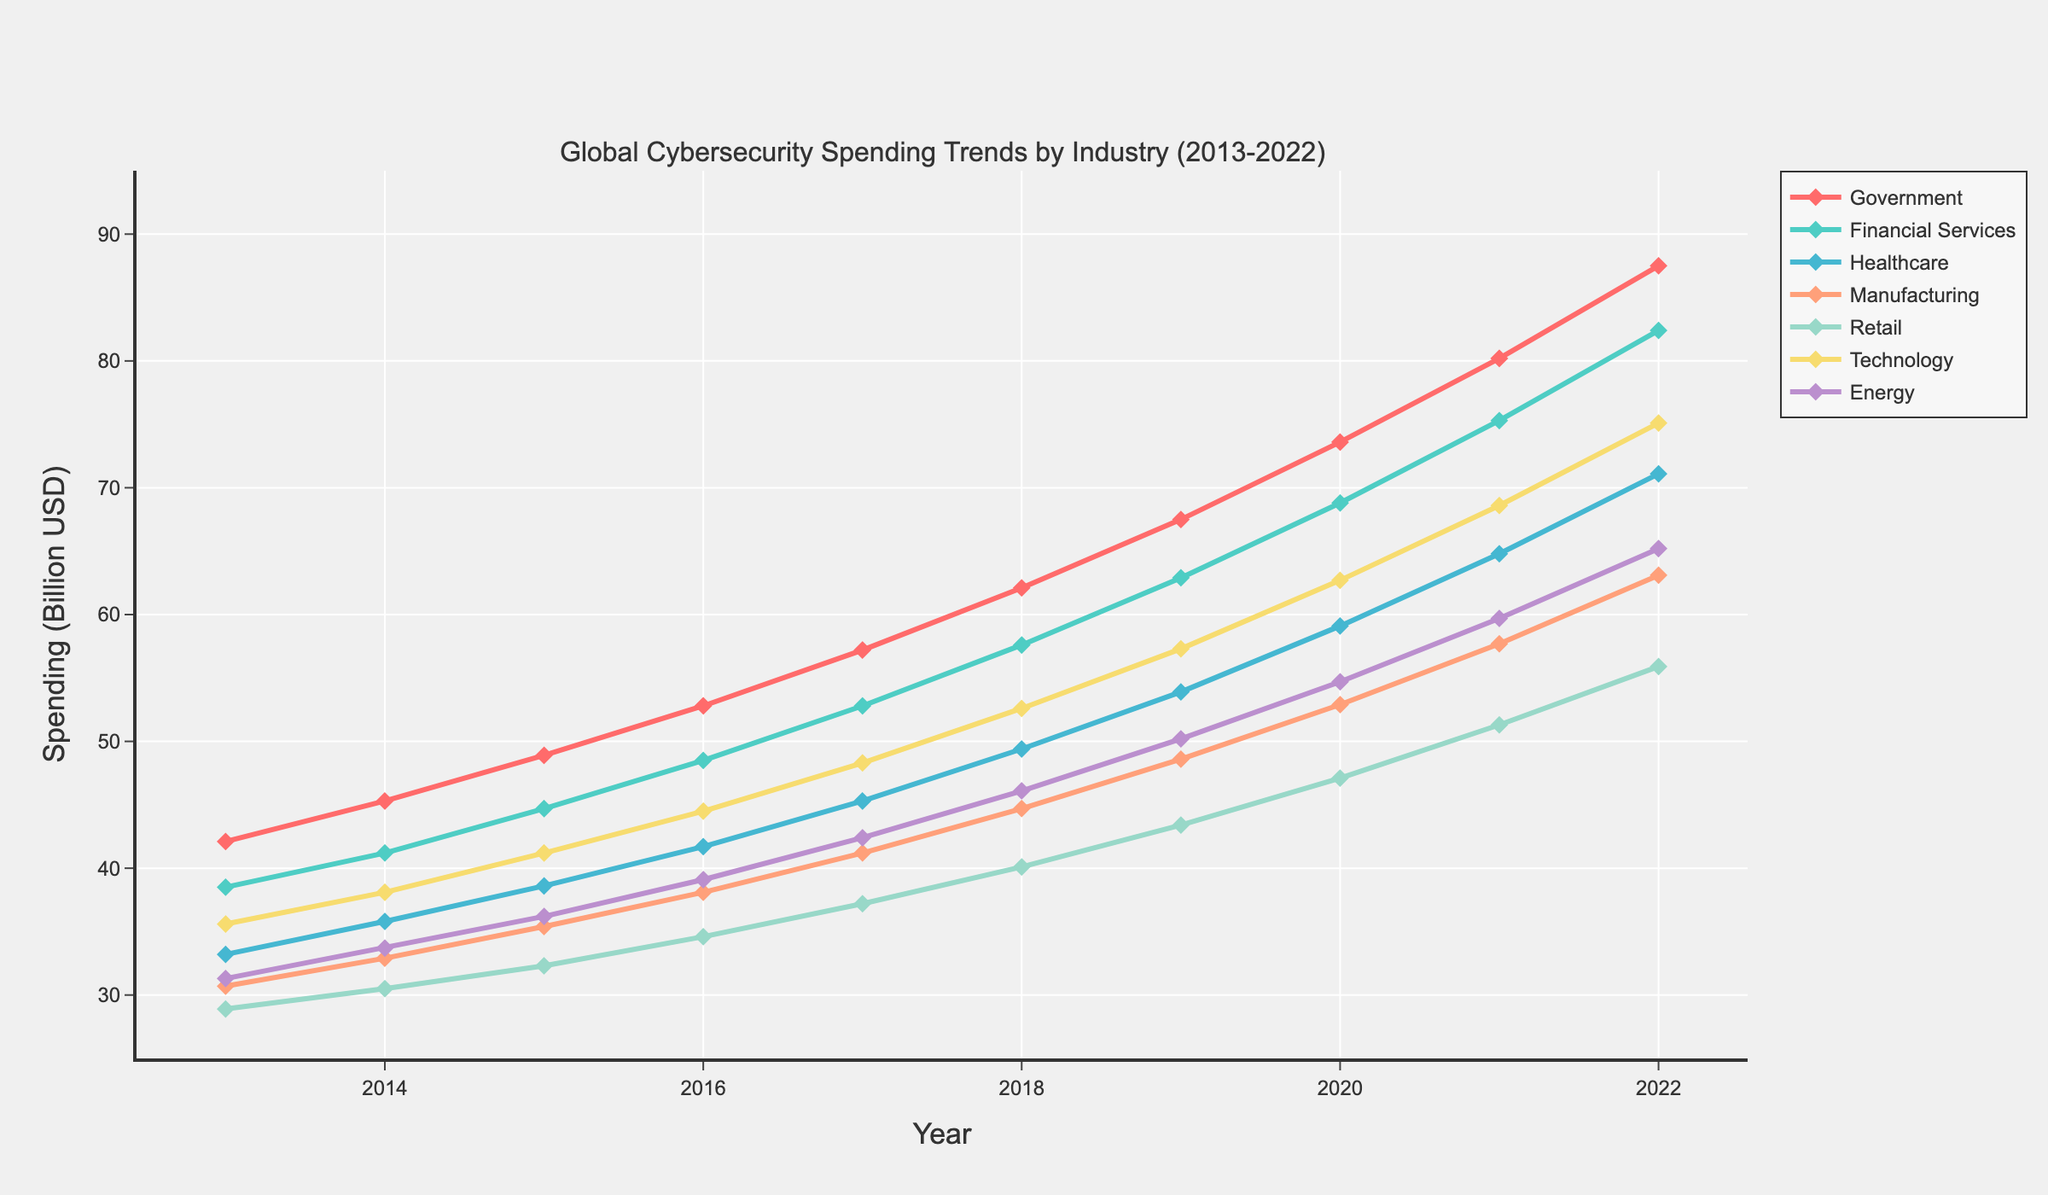What's the difference in cybersecurity spending between the Government and Retail sectors in 2022? The plot shows that cybersecurity spending in the Government sector in 2022 is 87.5 billion USD, whereas in the Retail sector, it is 55.9 billion USD. The difference is 87.5 - 55.9
Answer: 31.6 billion USD Which industry had the least increase in spending from 2013 to 2022? To determine which industry had the least increase, we subtract the 2013 spending from the 2022 spending for each sector and compare the results. Retail grew from 28.9 to 55.9 billion USD, which is an increase of 27 billion USD, the smallest across sectors.
Answer: Retail What was the growth rate of the Technology sector's spending from 2013 to 2022? The Technology sector's spending in 2013 was 35.6 billion USD and increased to 75.1 billion USD in 2022. The growth can be calculated as ((75.1 - 35.6) / 35.6) * 100%. This equals (39.5 / 35.6) * 100% = 110.96%
Answer: ~111% Which sector had the highest cybersecurity spending in 2017, and what was that amount? Referring to the 2017 data points, the Government sector had the highest spending at 57.2 billion USD.
Answer: Government, 57.2 billion USD What is the average annual cybersecurity spending in the Financial Services sector from 2013 to 2022? Adding the values from 2013 to 2022 for Financial Services gives: 38.5 + 41.2 + 44.7 + 48.5 + 52.8 + 57.6 + 62.9 + 68.8 + 75.3 + 82.4 = 572.7 billion USD. Dividing by 10 years, the average is 572.7/10
Answer: 57.3 billion USD How many more billion USD did the Healthcare sector spend on cybersecurity in 2021 compared to 2015? The Healthcare sector's spending was 64.8 billion USD in 2021 and 38.6 billion USD in 2015. The difference is 64.8 - 38.6
Answer: 26.2 billion USD Which sector shows the steepest positive slope in cybersecurity spending from 2019 to 2020? Observing the plotted lines, The Government sector shows the steepest increase from 67.5 to 73.6 billion USD, representing a 6.1 billion USD increase, the highest among all sectors.
Answer: Government 